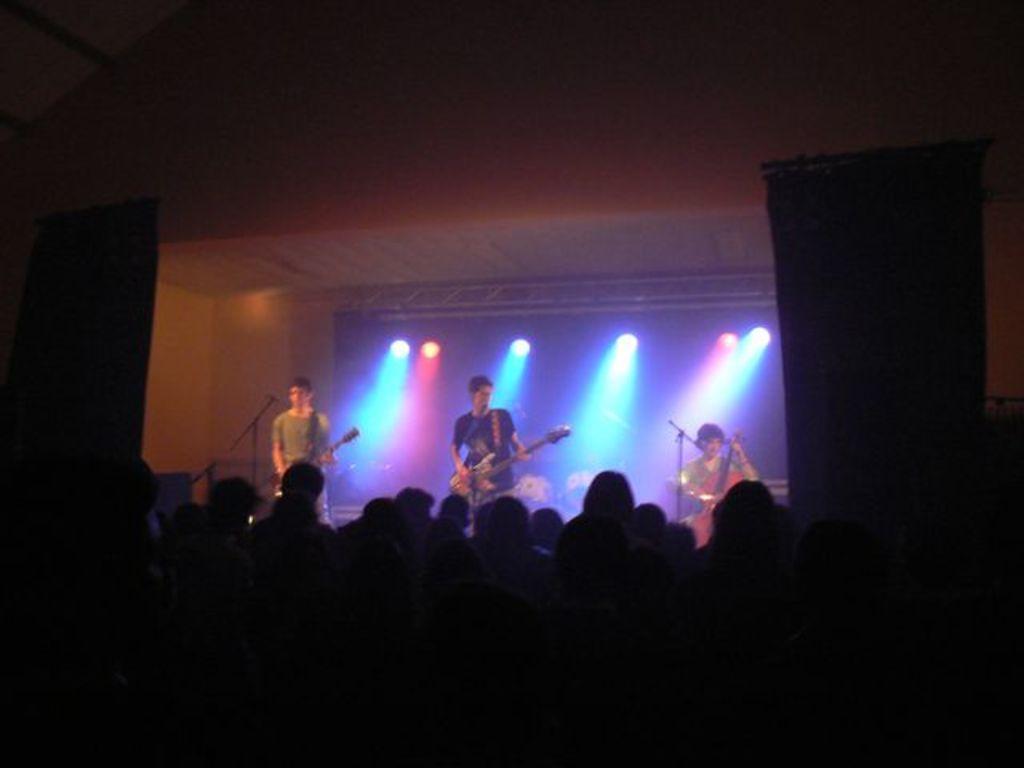Can you describe this image briefly? There are two persons standing and playing guitar in front of a mic and there is another person sitting and playing violin in front of mic beside them and there are audience in front of them. 